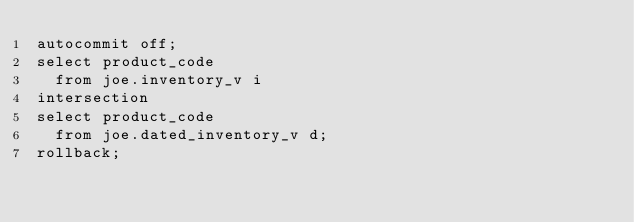<code> <loc_0><loc_0><loc_500><loc_500><_SQL_>autocommit off;
select product_code
  from joe.inventory_v i
intersection
select product_code
  from joe.dated_inventory_v d;
rollback;
</code> 